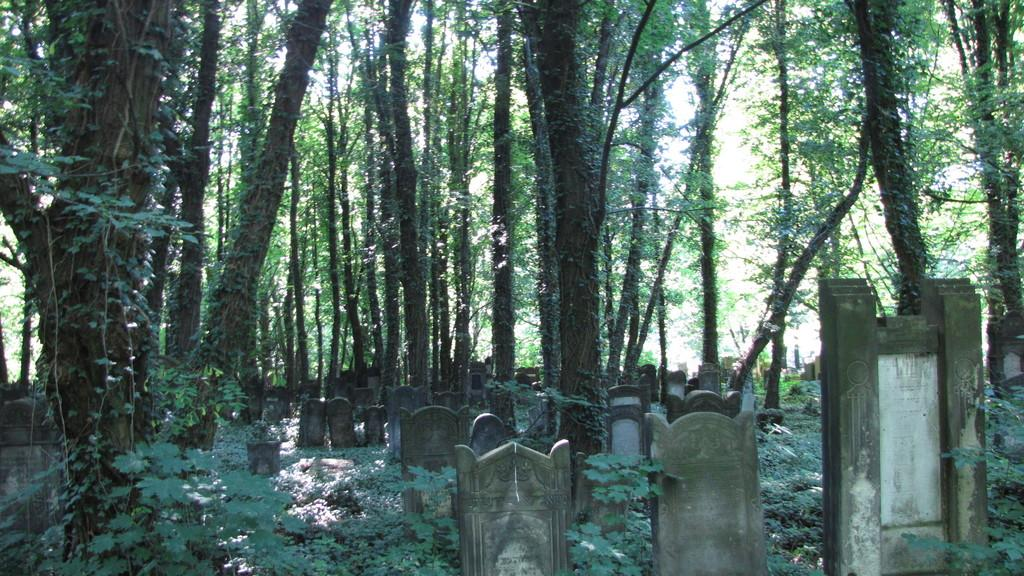What type of structures are present in the image? There are gravestones in the image. What type of vegetation can be seen in the image? There are trees and plants in the image. What time of day is it in the image, and what is the name of the fictional character who has a large nose? The time of day cannot be determined from the image, as there are no indications of time. Additionally, the name of a fictional character with a large nose is not present in the image. 